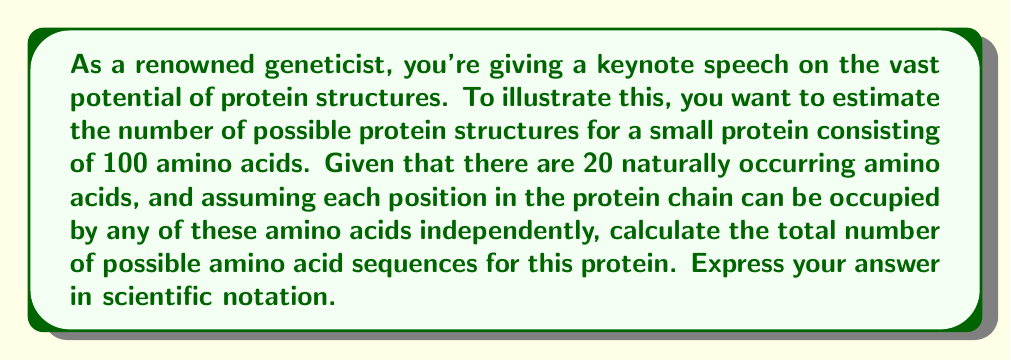Teach me how to tackle this problem. To solve this problem, we need to apply the fundamental counting principle. Here's a step-by-step explanation:

1. We have a protein chain with 100 positions.
2. For each position, we have 20 choices (the 20 naturally occurring amino acids).
3. The choices for each position are independent of the others.
4. According to the fundamental counting principle, when we have a series of independent choices, we multiply the number of possibilities for each choice.

Therefore, the total number of possible sequences is:

$$ 20 \times 20 \times 20 \times ... \text{ (100 times)} $$

This can be written as an exponent:

$$ 20^{100} $$

To calculate this:

1. $20^{100} = (2 \times 10)^{100} = 2^{100} \times 10^{100}$
2. $2^{100} \approx 1.2676506 \times 10^{30}$

Combining these:

$$ 20^{100} \approx 1.2676506 \times 10^{30} \times 10^{100} = 1.2676506 \times 10^{130} $$

Rounding to 3 significant figures:

$$ 20^{100} \approx 1.27 \times 10^{130} $$
Answer: $1.27 \times 10^{130}$ 